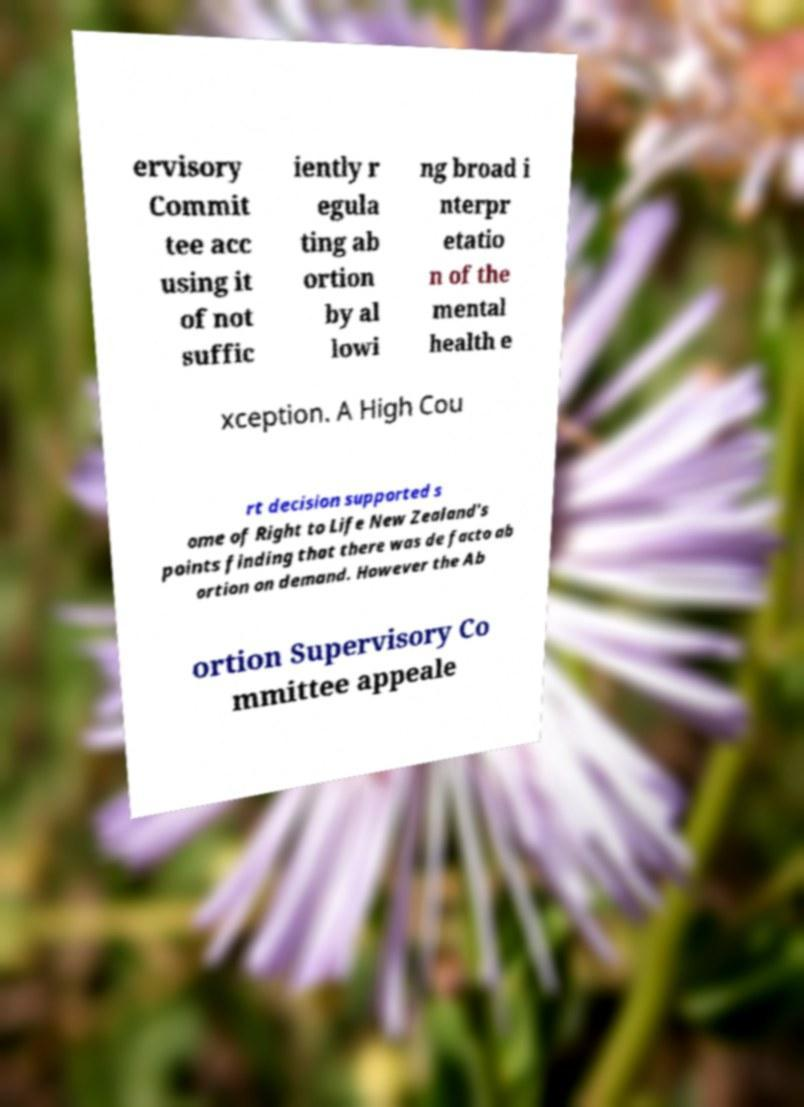Please read and relay the text visible in this image. What does it say? ervisory Commit tee acc using it of not suffic iently r egula ting ab ortion by al lowi ng broad i nterpr etatio n of the mental health e xception. A High Cou rt decision supported s ome of Right to Life New Zealand's points finding that there was de facto ab ortion on demand. However the Ab ortion Supervisory Co mmittee appeale 